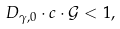Convert formula to latex. <formula><loc_0><loc_0><loc_500><loc_500>D _ { \gamma , 0 } \cdot c \cdot \mathcal { G } < 1 ,</formula> 